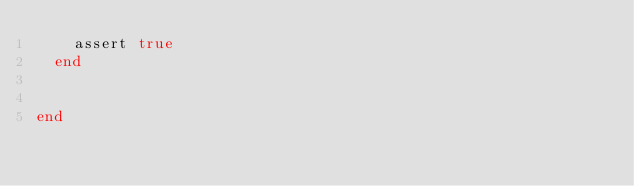<code> <loc_0><loc_0><loc_500><loc_500><_Ruby_>    assert true
  end


end</code> 